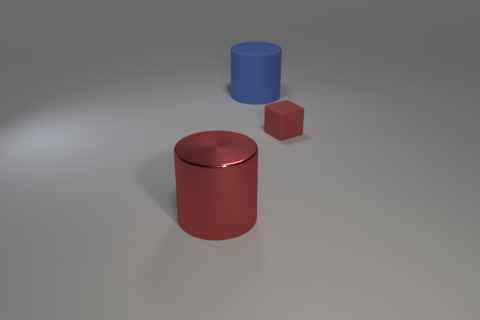What number of cylinders are the same color as the block?
Offer a terse response. 1. Is the size of the blue object the same as the block?
Make the answer very short. No. What material is the small red object?
Provide a short and direct response. Rubber. The object that is made of the same material as the big blue cylinder is what color?
Offer a terse response. Red. Are the large blue thing and the big object that is in front of the red matte block made of the same material?
Keep it short and to the point. No. How many other blue things are the same material as the blue object?
Offer a terse response. 0. What is the shape of the rubber object that is in front of the large blue object?
Your answer should be compact. Cube. Are the red object that is behind the metal cylinder and the large cylinder that is left of the large matte object made of the same material?
Provide a succinct answer. No. Are there any other shiny things of the same shape as the large red object?
Your answer should be very brief. No. How many objects are either cylinders that are behind the shiny cylinder or red cylinders?
Keep it short and to the point. 2. 